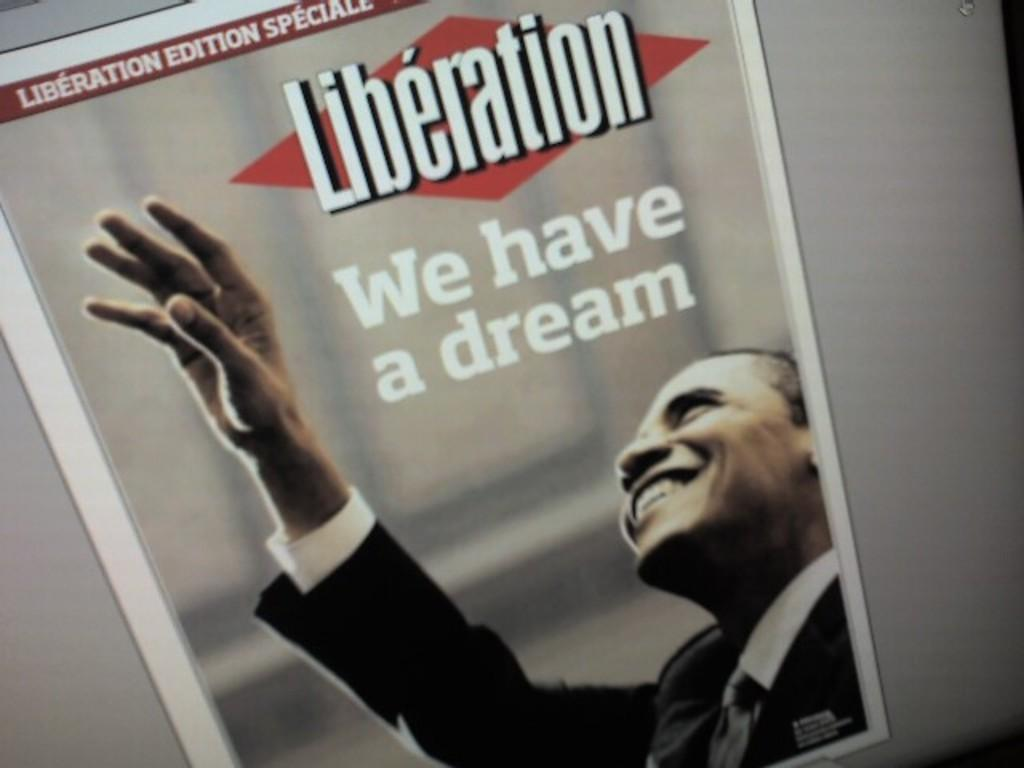What is located in the foreground of the image? There is a screen in the foreground of the image. What is displayed on the screen? There is a poster on the screen. What type of hose can be seen in the image? There is no hose present in the image; it only features a screen with a poster on it. 